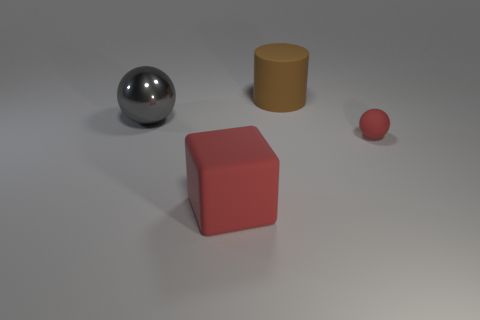Subtract all gray balls. How many balls are left? 1 Add 2 metallic objects. How many objects exist? 6 Subtract 0 blue cylinders. How many objects are left? 4 Subtract all cubes. How many objects are left? 3 Subtract 1 cylinders. How many cylinders are left? 0 Subtract all blue cylinders. Subtract all green cubes. How many cylinders are left? 1 Subtract all gray cylinders. How many brown spheres are left? 0 Subtract all gray shiny objects. Subtract all large red matte cubes. How many objects are left? 2 Add 1 rubber cubes. How many rubber cubes are left? 2 Add 1 tiny purple matte blocks. How many tiny purple matte blocks exist? 1 